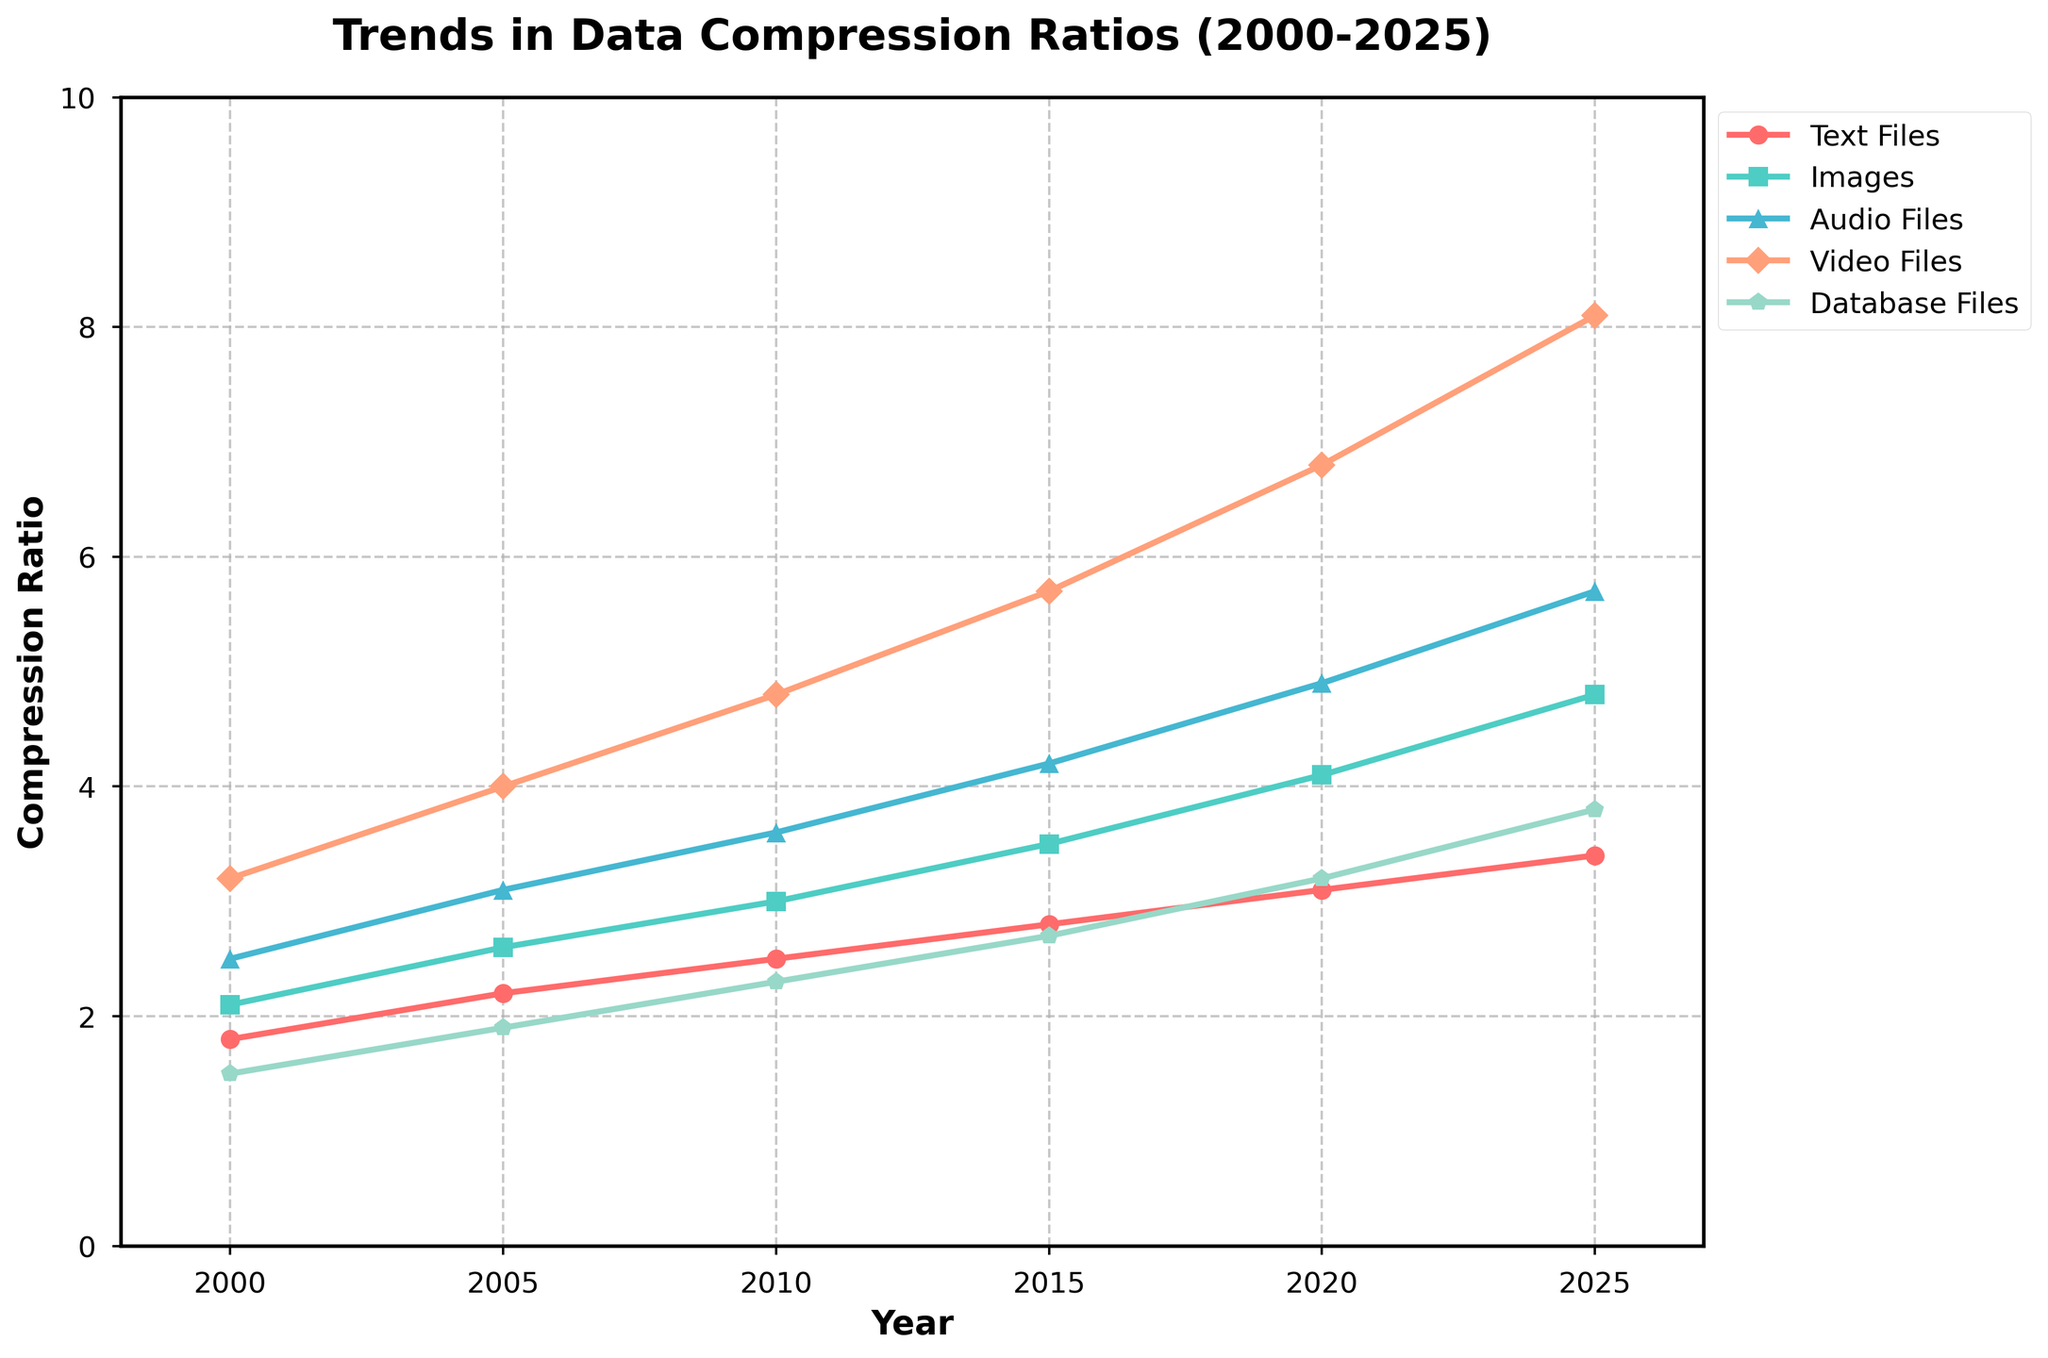What is the compression ratio trend for text files from 2000 to 2025? The compression ratio trend for text files shows a steady increase over the period. It starts at 1.8 in 2000 and goes up to 3.4 by 2025.
Answer: Increasing Which file type has the highest compression ratio in 2025? By examining the year 2025 on the x-axis, the video files have the highest compression ratio, reaching 8.1.
Answer: Video Files How does the compression ratio of audio files change between 2005 and 2015? In 2005, the compression ratio for audio files is 3.1. By 2015, it increases to 4.2. Therefore, the change in compression ratio is 4.2 - 3.1 = 1.1.
Answer: Increased by 1.1 Which file type shows the most gradual increase in compression ratio over the years? Observing the slopes of the lines, database files increase from 1.5 in 2000 to 3.8 in 2025, but at a more gradual rate compared to other types.
Answer: Database Files Compare the compression ratio of images and videos in the year 2010. In 2010, the compression ratio for images is 3.0, while for videos, it is 4.8. Thus, videos have a higher compression ratio compared to images by 4.8 - 3.0 = 1.8.
Answer: Videos higher by 1.8 Which file type had the lowest compression ratio in 2000 and what was it? Looking at the year 2000, database files have the lowest compression ratio at 1.5.
Answer: Database Files, 1.5 By how much did the compression ratio of images increase between 2000 and 2020? The compression ratio for images in 2000 is 2.1, and in 2020, it is 4.1. The increase is 4.1 - 2.1 = 2.0.
Answer: Increased by 2.0 Is the compression ratio growth rate of video files faster than that of audio files? For video files: 6.8 - 3.2 = 3.6 (2000-2020). For audio files: 4.9 - 2.5 = 2.4 (2000-2020). The growth rate for video files (3.6) is faster than for audio files (2.4).
Answer: Yes, faster What is the average compression ratio for text files across all years presented? Sum the compression ratios for text files from 2000 to 2025 (1.8 + 2.2 + 2.5 + 2.8 + 3.1 + 3.4) and divide by 6. (1.8 + 2.2 + 2.5 + 2.8 + 3.1 + 3.4) / 6 = 15.8 / 6 = 2.63
Answer: 2.63 